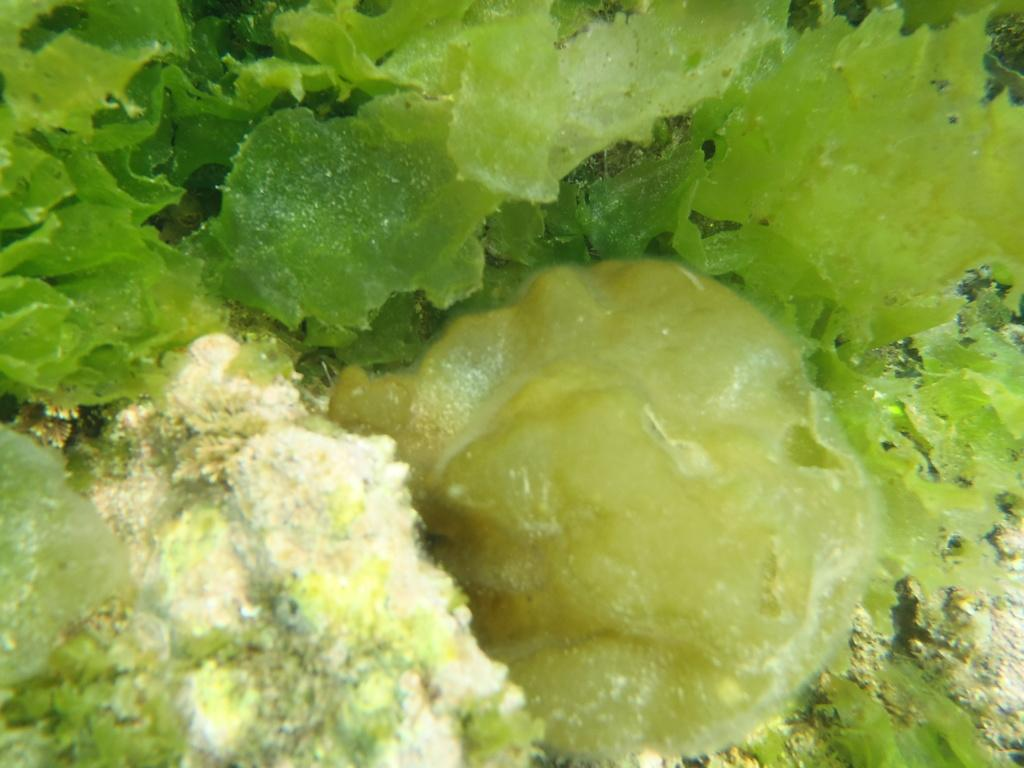What colors are present in the objects visible in the image? The objects in the image are green and cream in color. Is there a hose visible at the seashore in the image? There is no hose or seashore present in the image; the objects are green and cream in color. 